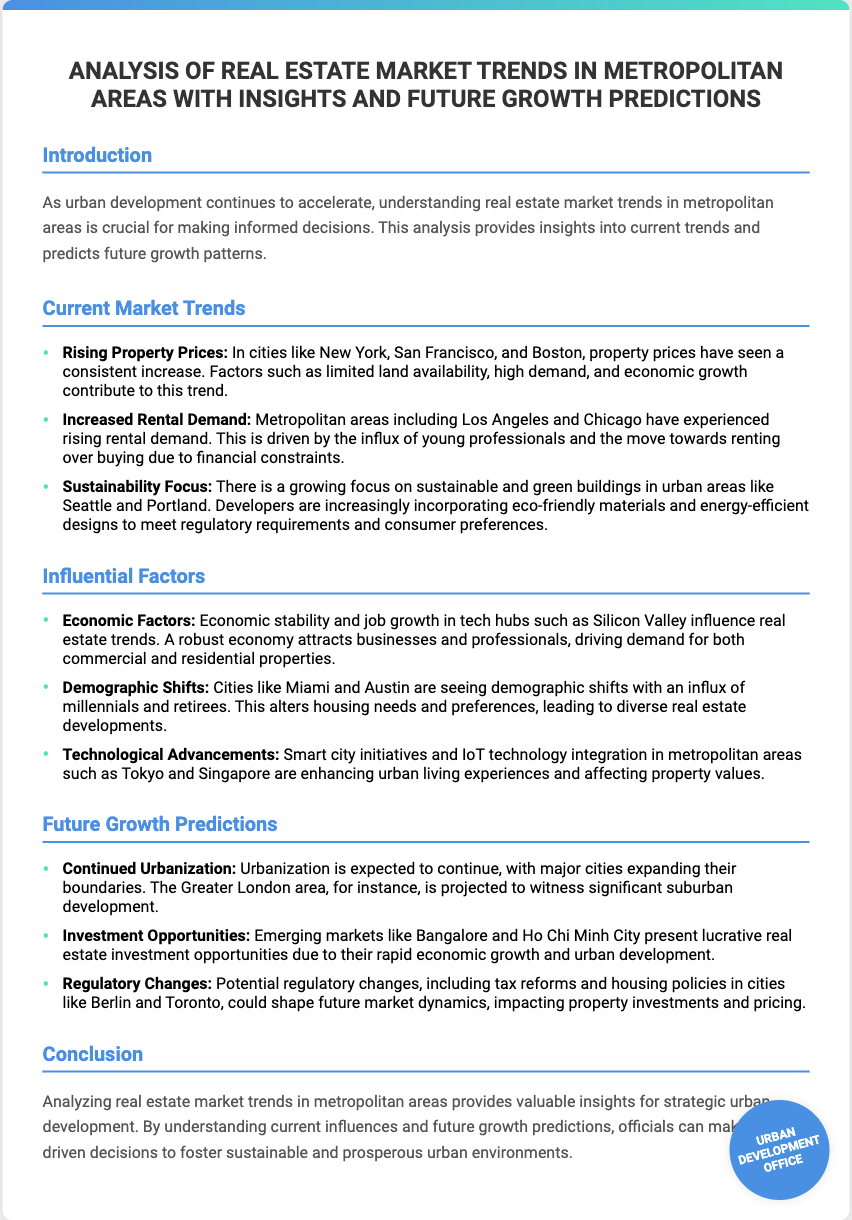What are the rising property prices attributed to? The document states that rising property prices are attributed to factors such as limited land availability, high demand, and economic growth.
Answer: Limited land availability, high demand, economic growth Which cities are experiencing increased rental demand? The analysis highlights that metropolitan areas including Los Angeles and Chicago are experiencing increased rental demand.
Answer: Los Angeles, Chicago What is one major focus in urban development mentioned? The document emphasizes a growing focus on sustainability and green buildings in urban areas like Seattle and Portland.
Answer: Sustainability focus What demographic shift is noted in Miami and Austin? The document notes that there is an influx of millennials and retirees in Miami and Austin, altering housing needs and preferences.
Answer: Influx of millennials and retirees What future growth is expected in the Greater London area? The document predicts significant suburban development in the Greater London area due to continued urbanization.
Answer: Significant suburban development What type of opportunities are emerging in Bangalore and Ho Chi Minh City? The analysis indicates that emerging markets like Bangalore and Ho Chi Minh City present lucrative real estate investment opportunities.
Answer: Lucrative investment opportunities What could potentially shape future market dynamics according to the document? The document suggests that potential regulatory changes, including tax reforms and housing policies, could shape future market dynamics.
Answer: Regulatory changes What is the purpose of analyzing real estate market trends? The document states that analyzing real estate market trends provides valuable insights for strategic urban development.
Answer: Valuable insights for strategic urban development 